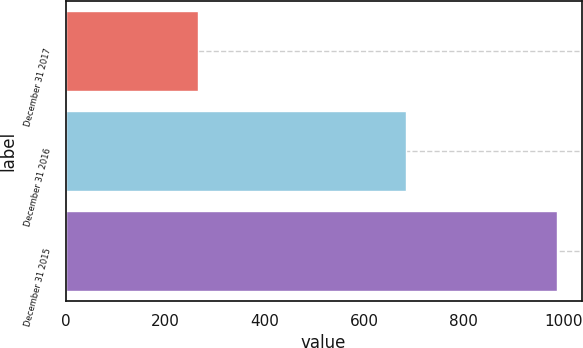Convert chart to OTSL. <chart><loc_0><loc_0><loc_500><loc_500><bar_chart><fcel>December 31 2017<fcel>December 31 2016<fcel>December 31 2015<nl><fcel>266<fcel>684<fcel>988<nl></chart> 